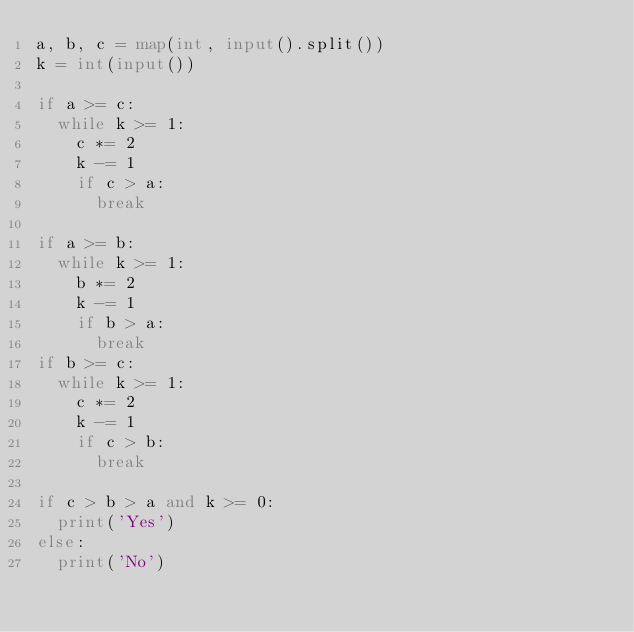Convert code to text. <code><loc_0><loc_0><loc_500><loc_500><_Python_>a, b, c = map(int, input().split())
k = int(input())

if a >= c:
  while k >= 1:
    c *= 2
    k -= 1
    if c > a:
      break

if a >= b:
  while k >= 1:
    b *= 2
    k -= 1
    if b > a:
      break
if b >= c:
  while k >= 1:
    c *= 2
    k -= 1
    if c > b:
      break

if c > b > a and k >= 0:
  print('Yes')
else:
  print('No')
    </code> 